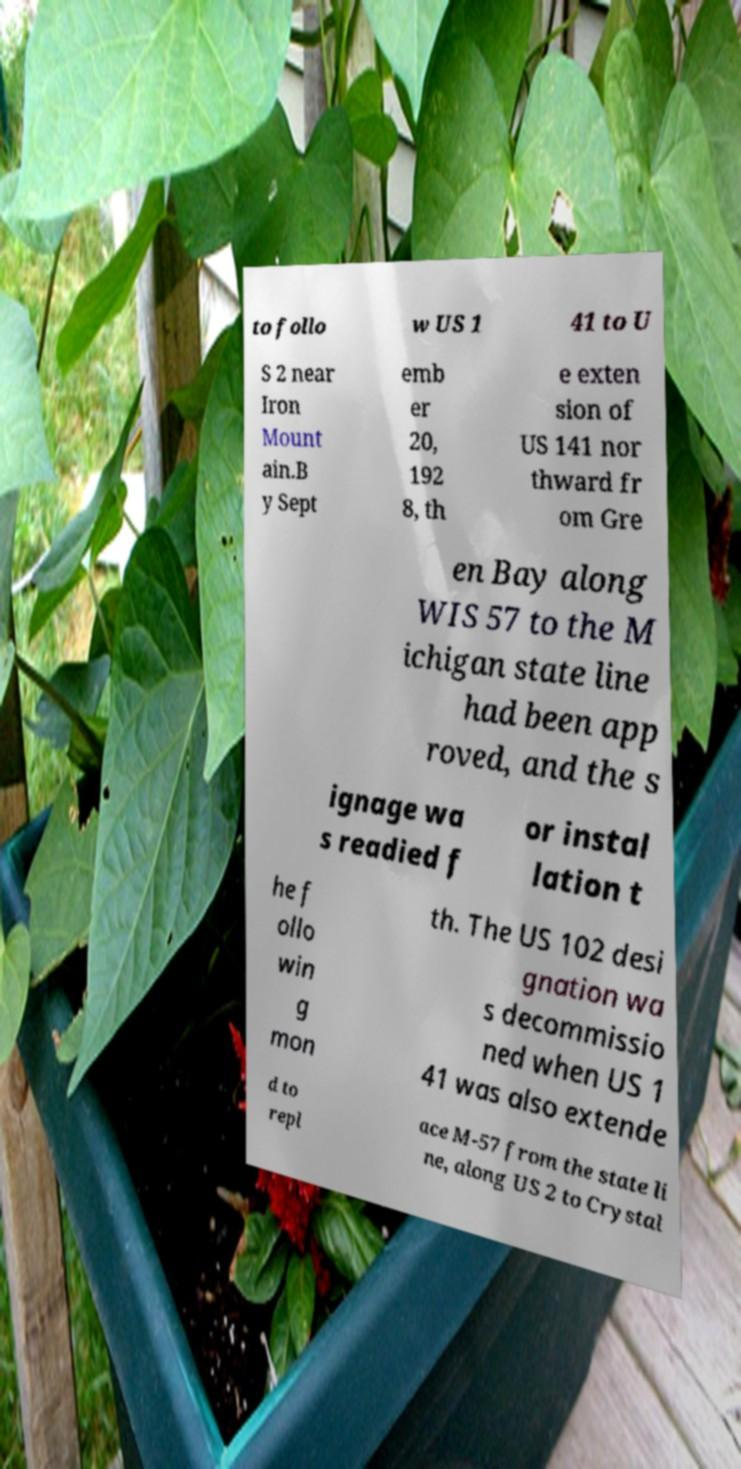Please identify and transcribe the text found in this image. to follo w US 1 41 to U S 2 near Iron Mount ain.B y Sept emb er 20, 192 8, th e exten sion of US 141 nor thward fr om Gre en Bay along WIS 57 to the M ichigan state line had been app roved, and the s ignage wa s readied f or instal lation t he f ollo win g mon th. The US 102 desi gnation wa s decommissio ned when US 1 41 was also extende d to repl ace M-57 from the state li ne, along US 2 to Crystal 